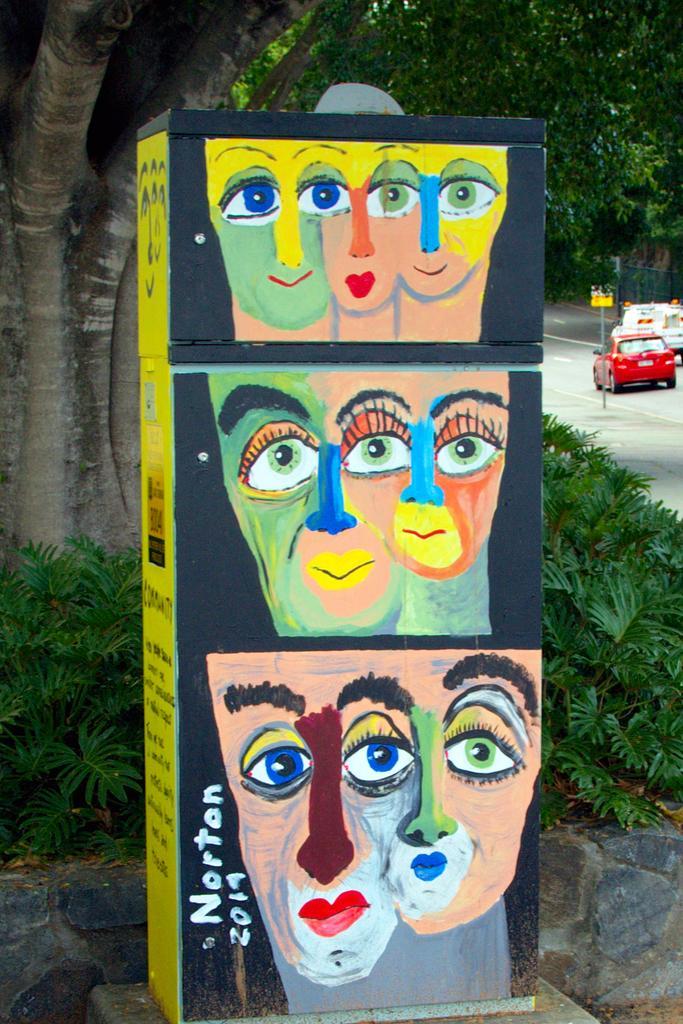Could you give a brief overview of what you see in this image? In this picture we can see a box with some text and a painting on it, plants, trees and in the background we can see vehicles on the road, pole with a board. 